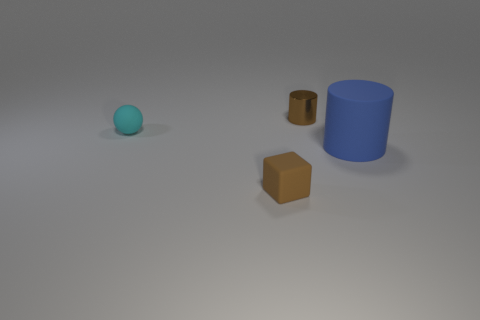Is there anything else that is the same material as the small brown cylinder?
Provide a succinct answer. No. Do the metal thing and the cube have the same color?
Provide a short and direct response. Yes. How many things are things that are to the right of the matte block or big objects?
Offer a very short reply. 2. Are there fewer small brown blocks on the right side of the blue thing than brown cylinders that are to the left of the tiny ball?
Your answer should be compact. No. How many other objects are there of the same size as the metallic cylinder?
Your response must be concise. 2. Is the cyan thing made of the same material as the tiny brown thing behind the small block?
Ensure brevity in your answer.  No. How many things are small brown things that are in front of the blue matte thing or blocks that are in front of the small cyan thing?
Make the answer very short. 1. What color is the cube?
Your answer should be compact. Brown. Is the number of large blue matte cylinders left of the tiny metallic cylinder less than the number of tiny things?
Provide a short and direct response. Yes. Is there anything else that is the same shape as the blue thing?
Provide a succinct answer. Yes. 